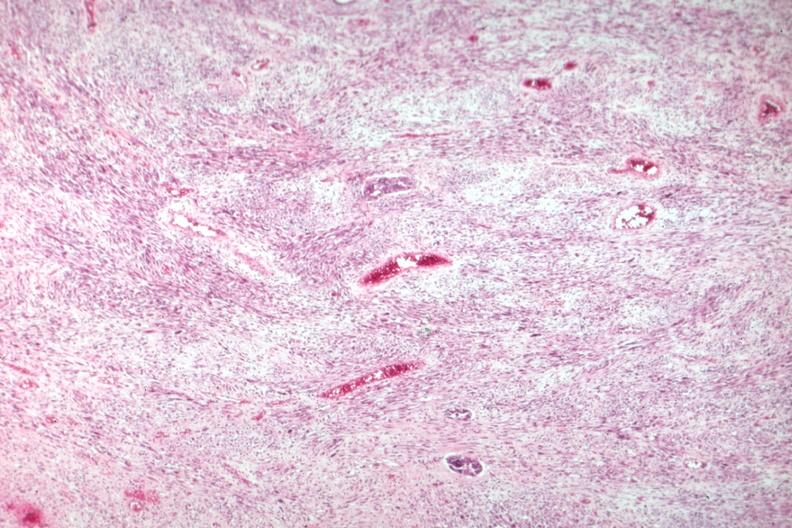s opened muscle present?
Answer the question using a single word or phrase. No 